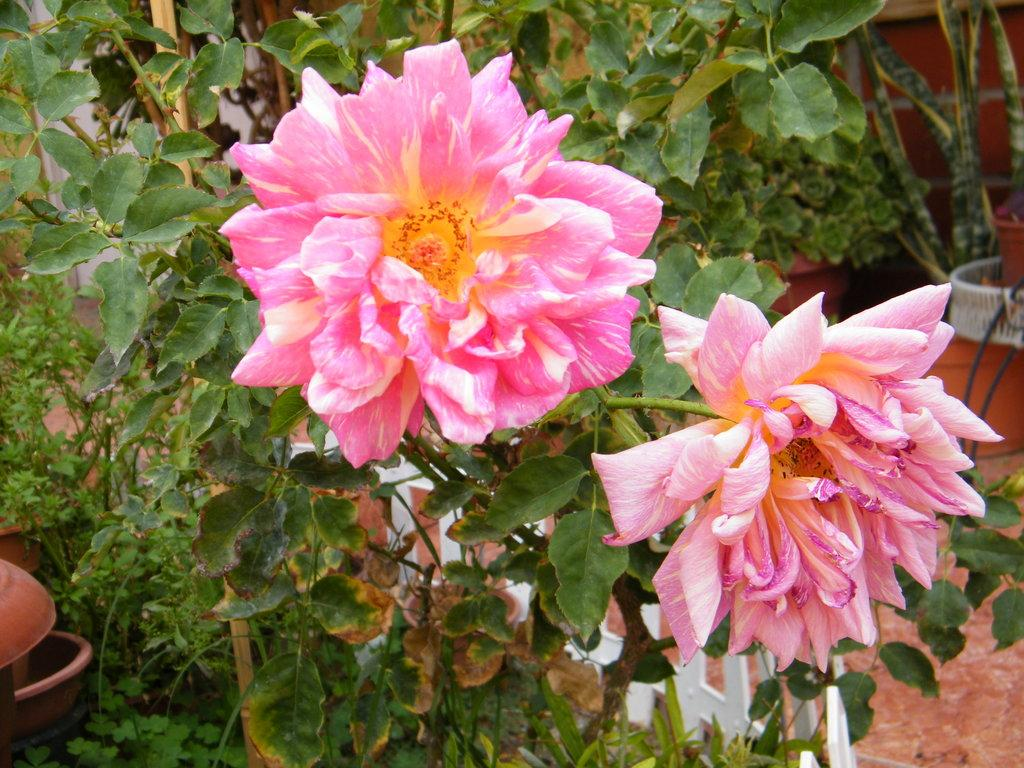What type of plants can be seen in the image? There are plants with flowers in the image. Are there any plants in containers in the image? Yes, there are potted plants in the background of the image. What can be seen in the foreground of the image? There is a white color fence in the image. What verse is being recited by the company in the image? There is no company or verse present in the image; it features plants with flowers and a white color fence. 